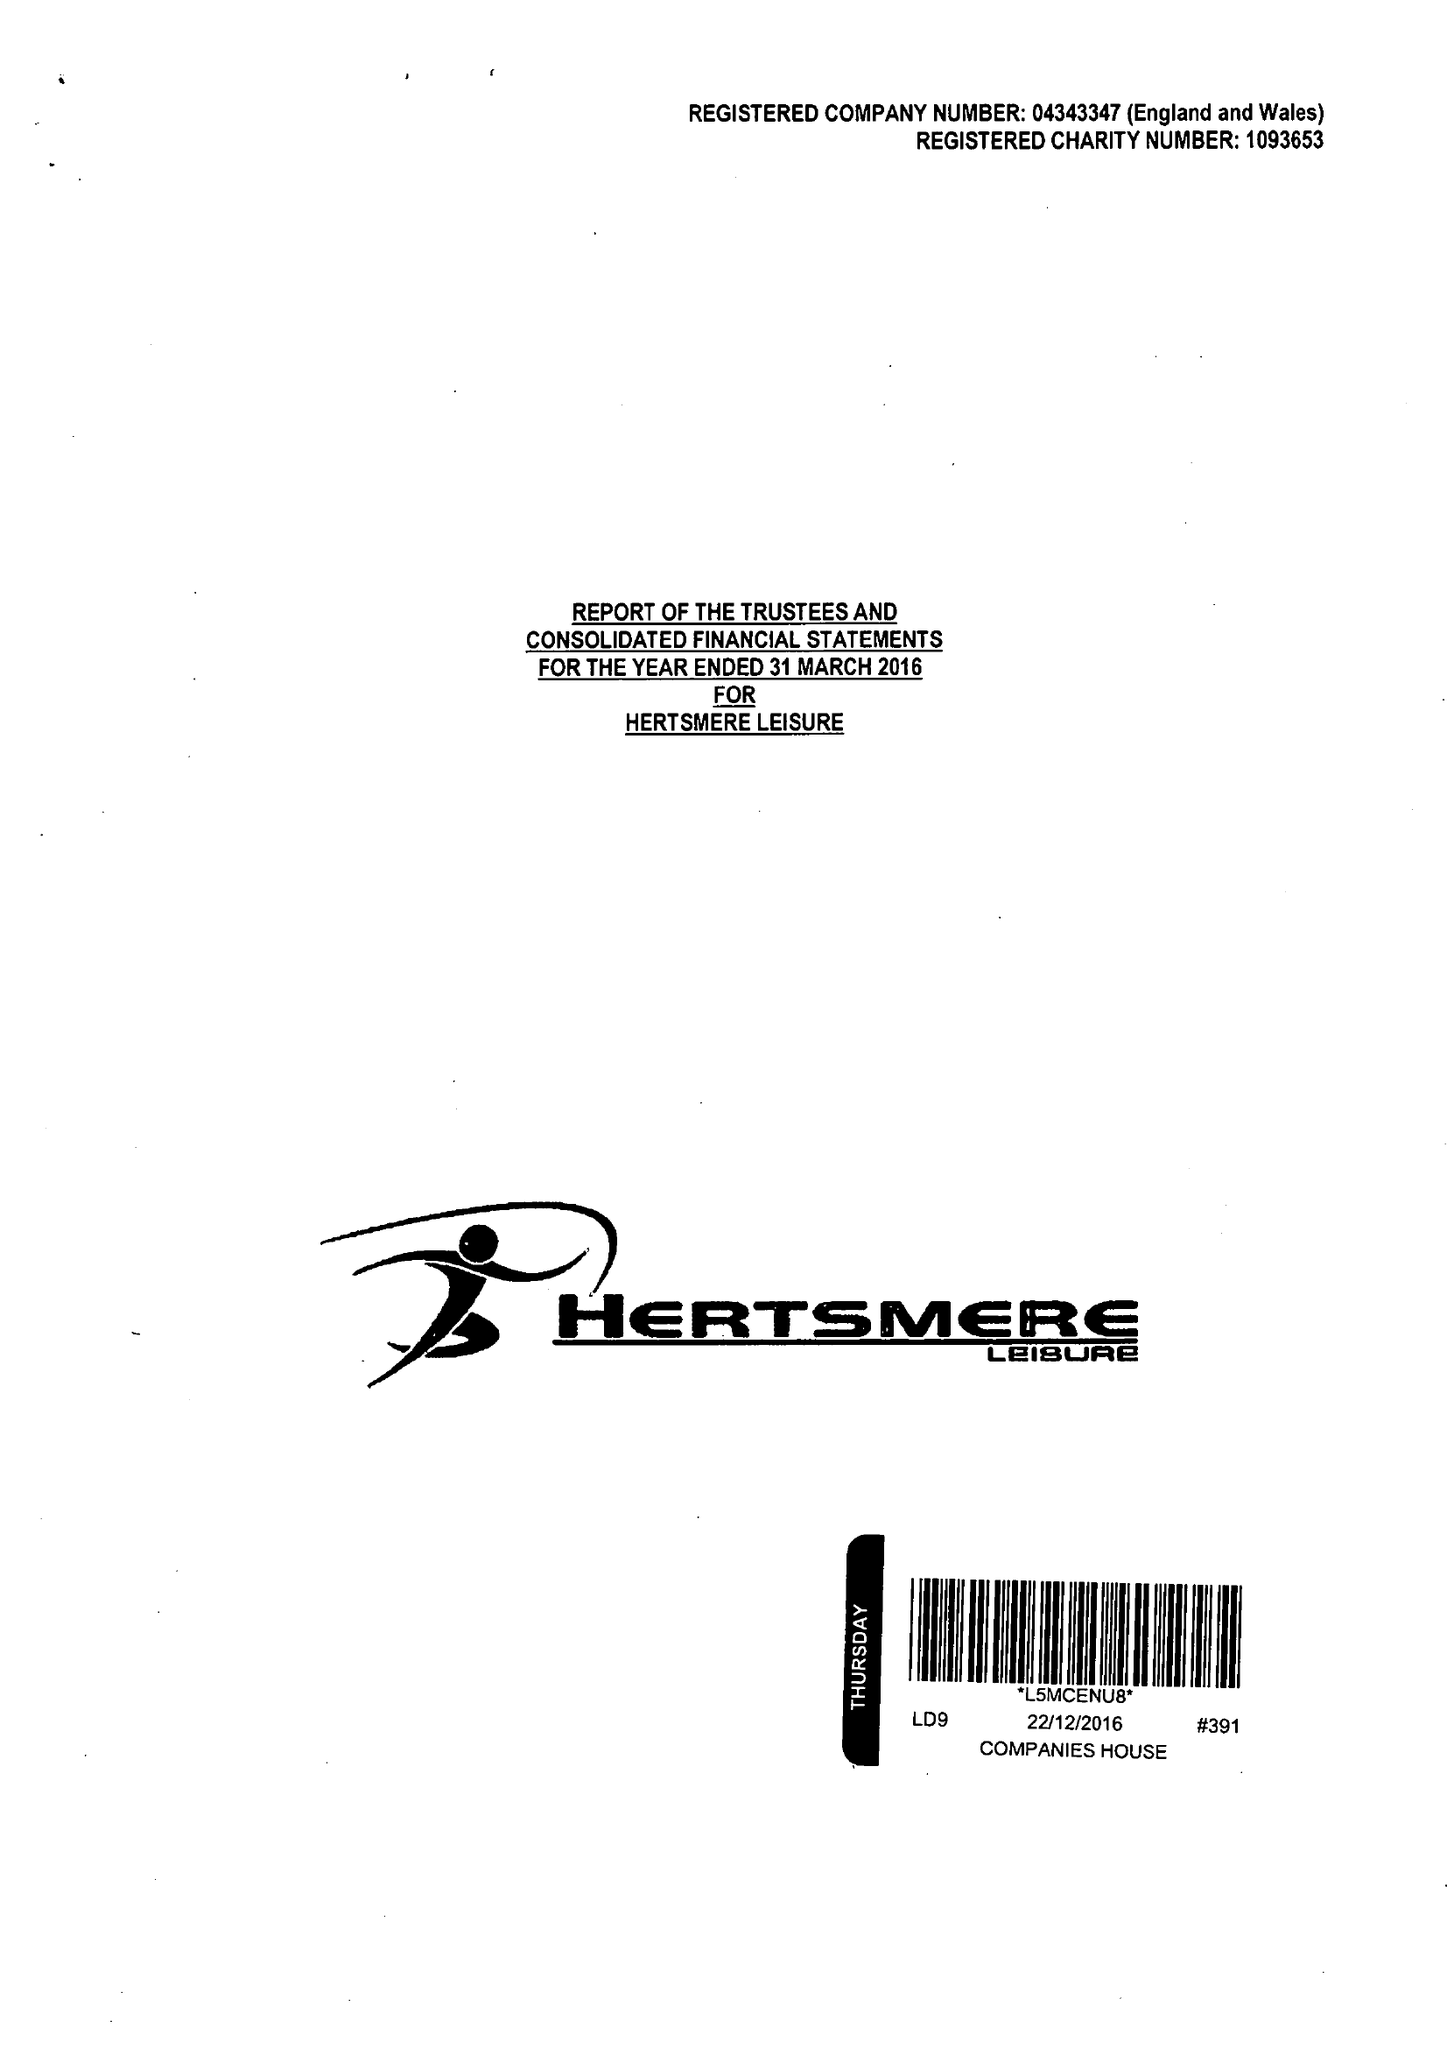What is the value for the report_date?
Answer the question using a single word or phrase. 2016-03-31 